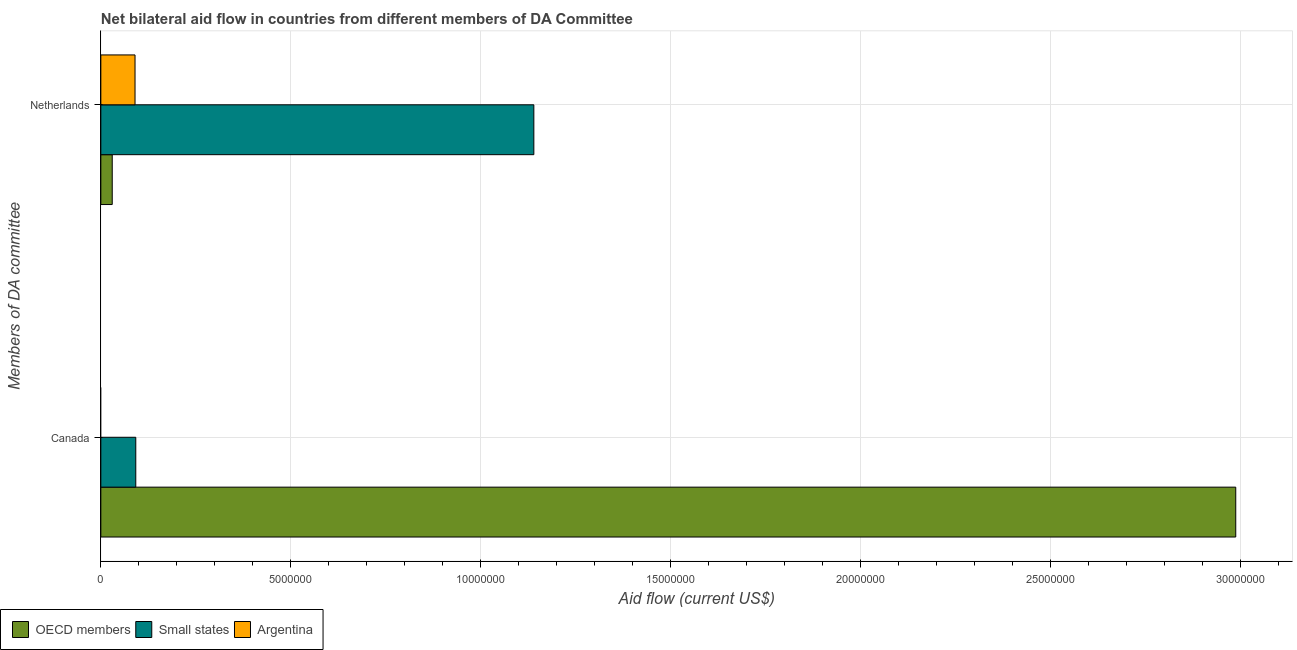How many different coloured bars are there?
Ensure brevity in your answer.  3. How many groups of bars are there?
Provide a succinct answer. 2. How many bars are there on the 1st tick from the bottom?
Give a very brief answer. 2. What is the label of the 2nd group of bars from the top?
Provide a short and direct response. Canada. What is the amount of aid given by canada in OECD members?
Provide a succinct answer. 2.99e+07. Across all countries, what is the maximum amount of aid given by netherlands?
Ensure brevity in your answer.  1.14e+07. Across all countries, what is the minimum amount of aid given by netherlands?
Give a very brief answer. 3.00e+05. In which country was the amount of aid given by netherlands maximum?
Your response must be concise. Small states. What is the total amount of aid given by canada in the graph?
Offer a very short reply. 3.08e+07. What is the difference between the amount of aid given by netherlands in OECD members and that in Argentina?
Make the answer very short. -6.00e+05. What is the difference between the amount of aid given by netherlands in OECD members and the amount of aid given by canada in Argentina?
Your answer should be very brief. 3.00e+05. What is the average amount of aid given by canada per country?
Your answer should be compact. 1.03e+07. What is the difference between the amount of aid given by canada and amount of aid given by netherlands in OECD members?
Offer a very short reply. 2.96e+07. What is the ratio of the amount of aid given by netherlands in Small states to that in Argentina?
Your answer should be compact. 12.67. Is the amount of aid given by canada in OECD members less than that in Small states?
Offer a terse response. No. How many bars are there?
Offer a very short reply. 5. How many countries are there in the graph?
Keep it short and to the point. 3. What is the difference between two consecutive major ticks on the X-axis?
Your answer should be compact. 5.00e+06. What is the title of the graph?
Give a very brief answer. Net bilateral aid flow in countries from different members of DA Committee. What is the label or title of the X-axis?
Give a very brief answer. Aid flow (current US$). What is the label or title of the Y-axis?
Offer a very short reply. Members of DA committee. What is the Aid flow (current US$) of OECD members in Canada?
Keep it short and to the point. 2.99e+07. What is the Aid flow (current US$) of Small states in Canada?
Your response must be concise. 9.20e+05. What is the Aid flow (current US$) of Argentina in Canada?
Your answer should be compact. 0. What is the Aid flow (current US$) in Small states in Netherlands?
Provide a short and direct response. 1.14e+07. What is the Aid flow (current US$) in Argentina in Netherlands?
Ensure brevity in your answer.  9.00e+05. Across all Members of DA committee, what is the maximum Aid flow (current US$) in OECD members?
Ensure brevity in your answer.  2.99e+07. Across all Members of DA committee, what is the maximum Aid flow (current US$) of Small states?
Give a very brief answer. 1.14e+07. Across all Members of DA committee, what is the minimum Aid flow (current US$) in Small states?
Your answer should be very brief. 9.20e+05. What is the total Aid flow (current US$) of OECD members in the graph?
Offer a very short reply. 3.02e+07. What is the total Aid flow (current US$) of Small states in the graph?
Provide a short and direct response. 1.23e+07. What is the total Aid flow (current US$) in Argentina in the graph?
Offer a terse response. 9.00e+05. What is the difference between the Aid flow (current US$) of OECD members in Canada and that in Netherlands?
Your answer should be compact. 2.96e+07. What is the difference between the Aid flow (current US$) in Small states in Canada and that in Netherlands?
Provide a succinct answer. -1.05e+07. What is the difference between the Aid flow (current US$) of OECD members in Canada and the Aid flow (current US$) of Small states in Netherlands?
Provide a succinct answer. 1.85e+07. What is the difference between the Aid flow (current US$) in OECD members in Canada and the Aid flow (current US$) in Argentina in Netherlands?
Your answer should be compact. 2.90e+07. What is the average Aid flow (current US$) of OECD members per Members of DA committee?
Your answer should be very brief. 1.51e+07. What is the average Aid flow (current US$) in Small states per Members of DA committee?
Make the answer very short. 6.16e+06. What is the average Aid flow (current US$) in Argentina per Members of DA committee?
Provide a succinct answer. 4.50e+05. What is the difference between the Aid flow (current US$) of OECD members and Aid flow (current US$) of Small states in Canada?
Ensure brevity in your answer.  2.90e+07. What is the difference between the Aid flow (current US$) in OECD members and Aid flow (current US$) in Small states in Netherlands?
Your answer should be compact. -1.11e+07. What is the difference between the Aid flow (current US$) in OECD members and Aid flow (current US$) in Argentina in Netherlands?
Keep it short and to the point. -6.00e+05. What is the difference between the Aid flow (current US$) of Small states and Aid flow (current US$) of Argentina in Netherlands?
Ensure brevity in your answer.  1.05e+07. What is the ratio of the Aid flow (current US$) in OECD members in Canada to that in Netherlands?
Make the answer very short. 99.6. What is the ratio of the Aid flow (current US$) of Small states in Canada to that in Netherlands?
Your answer should be very brief. 0.08. What is the difference between the highest and the second highest Aid flow (current US$) in OECD members?
Make the answer very short. 2.96e+07. What is the difference between the highest and the second highest Aid flow (current US$) of Small states?
Make the answer very short. 1.05e+07. What is the difference between the highest and the lowest Aid flow (current US$) of OECD members?
Offer a very short reply. 2.96e+07. What is the difference between the highest and the lowest Aid flow (current US$) of Small states?
Provide a short and direct response. 1.05e+07. What is the difference between the highest and the lowest Aid flow (current US$) in Argentina?
Offer a very short reply. 9.00e+05. 